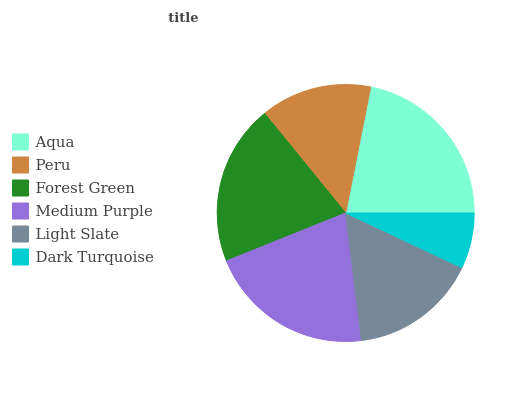Is Dark Turquoise the minimum?
Answer yes or no. Yes. Is Aqua the maximum?
Answer yes or no. Yes. Is Peru the minimum?
Answer yes or no. No. Is Peru the maximum?
Answer yes or no. No. Is Aqua greater than Peru?
Answer yes or no. Yes. Is Peru less than Aqua?
Answer yes or no. Yes. Is Peru greater than Aqua?
Answer yes or no. No. Is Aqua less than Peru?
Answer yes or no. No. Is Forest Green the high median?
Answer yes or no. Yes. Is Light Slate the low median?
Answer yes or no. Yes. Is Dark Turquoise the high median?
Answer yes or no. No. Is Aqua the low median?
Answer yes or no. No. 